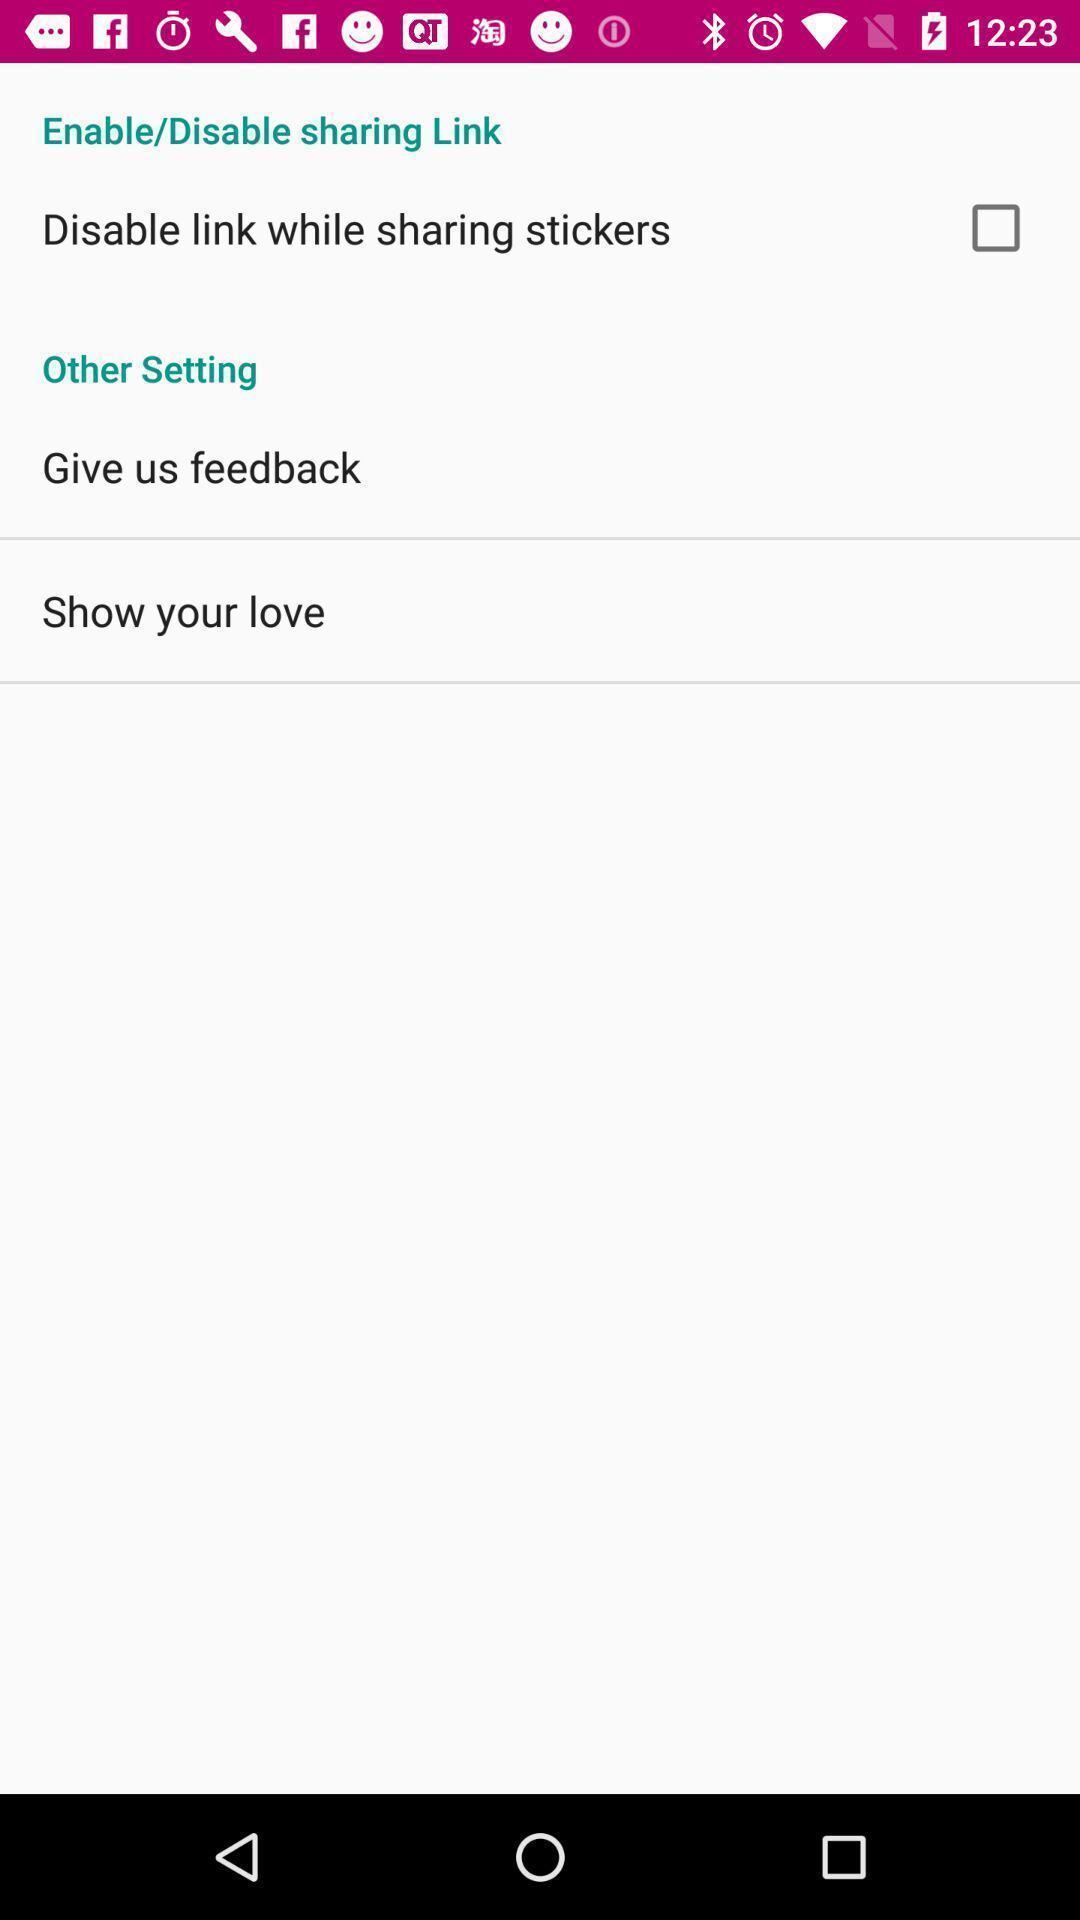Give me a narrative description of this picture. Page showing different settings on an emoji sharing app. 